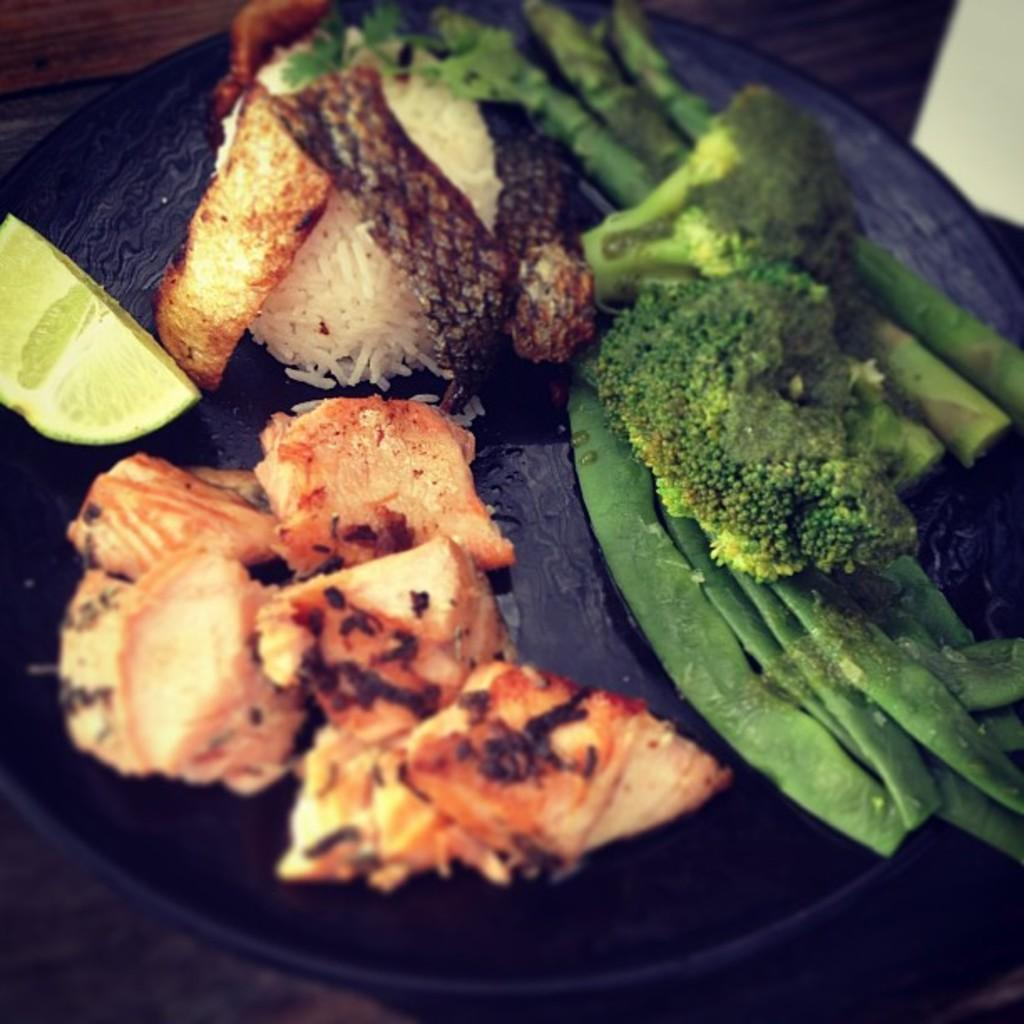What object is present on the plate in the image? The plate contains broccoli leaves and a lemon piece. What type of food is on the plate? There is food stuff on the plate, including broccoli leaves and a lemon piece. Can you see any roses in the alley near the plate in the image? There is no alley or rose present in the image; it only features a plate with broccoli leaves and a lemon piece. 